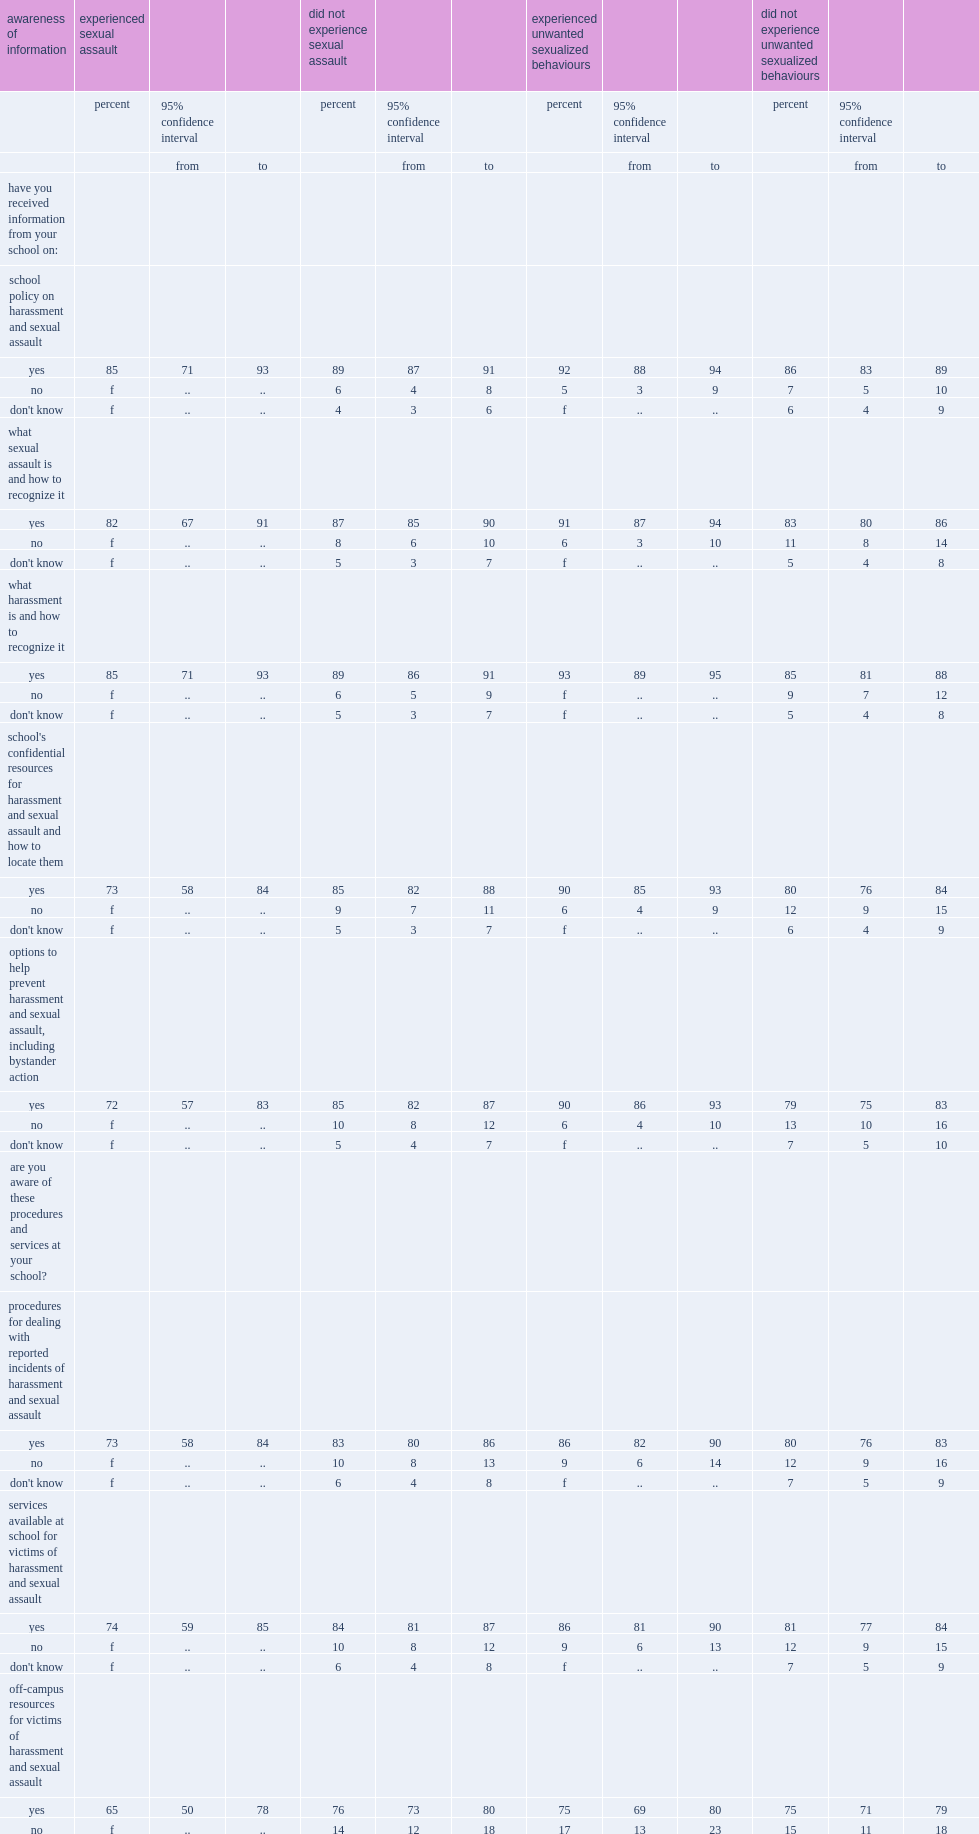What was the percent of students who were sexually assaulted in the previous 12 months said they knew where to get help at school if a friend was harassed or sexually assaulted? 68.0. What was the percent of students who were not sexually assaulted? 81.0. 